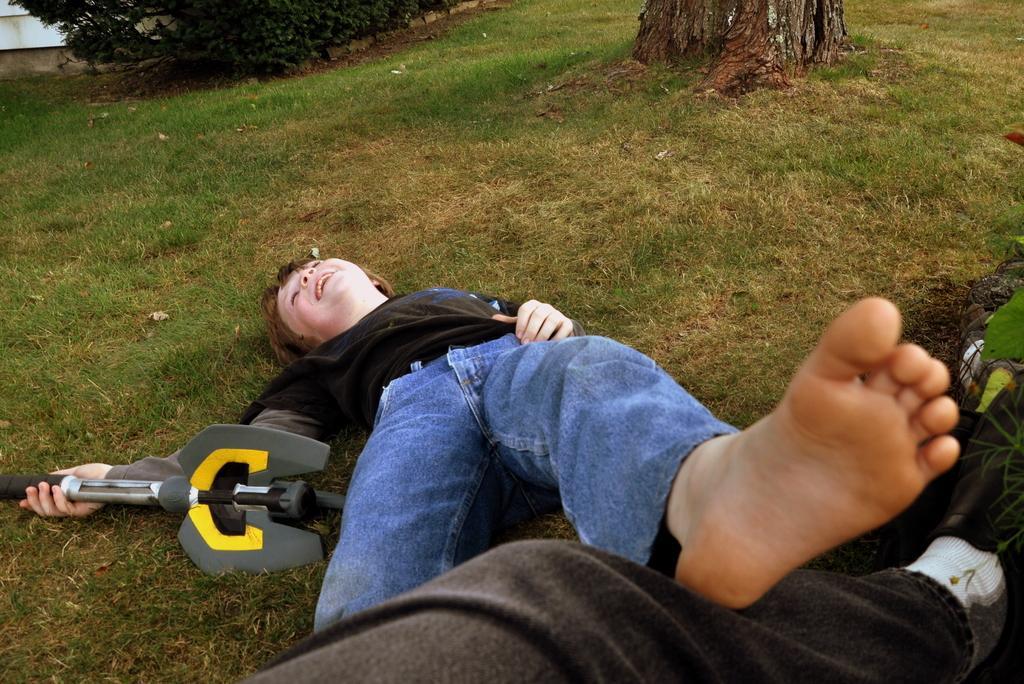Please provide a concise description of this image. In this picture I can see a boy who is lying on the grass and is holding a thing and I see that he kept one of his leg on a person's leg. In the background I can see a tree and few plants. 